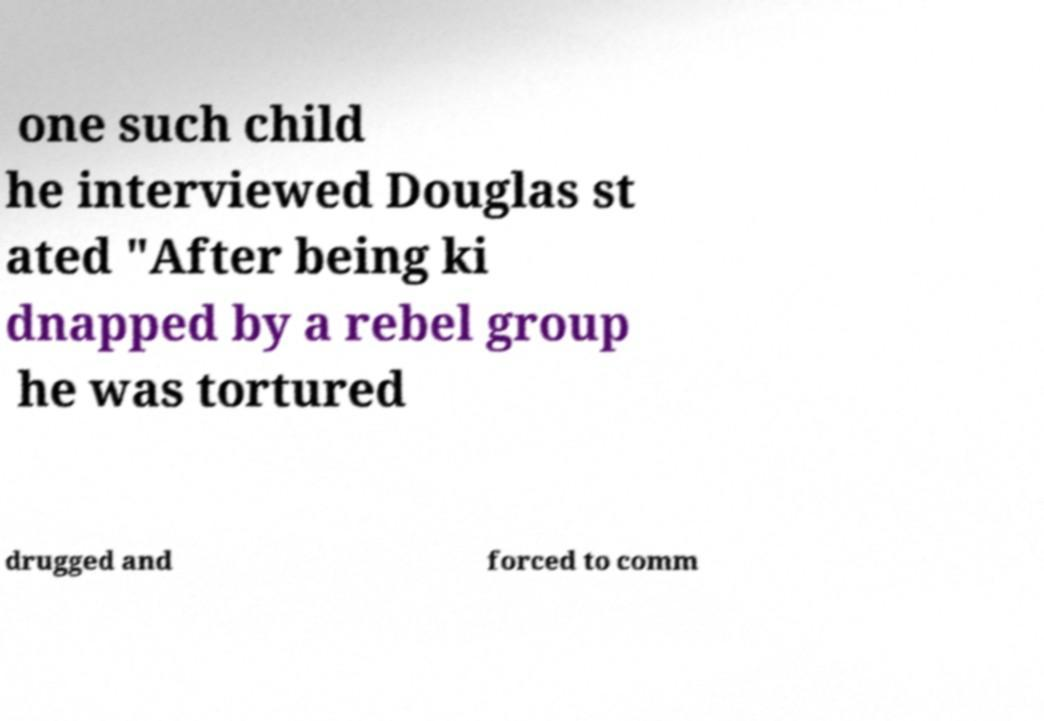Please identify and transcribe the text found in this image. one such child he interviewed Douglas st ated "After being ki dnapped by a rebel group he was tortured drugged and forced to comm 